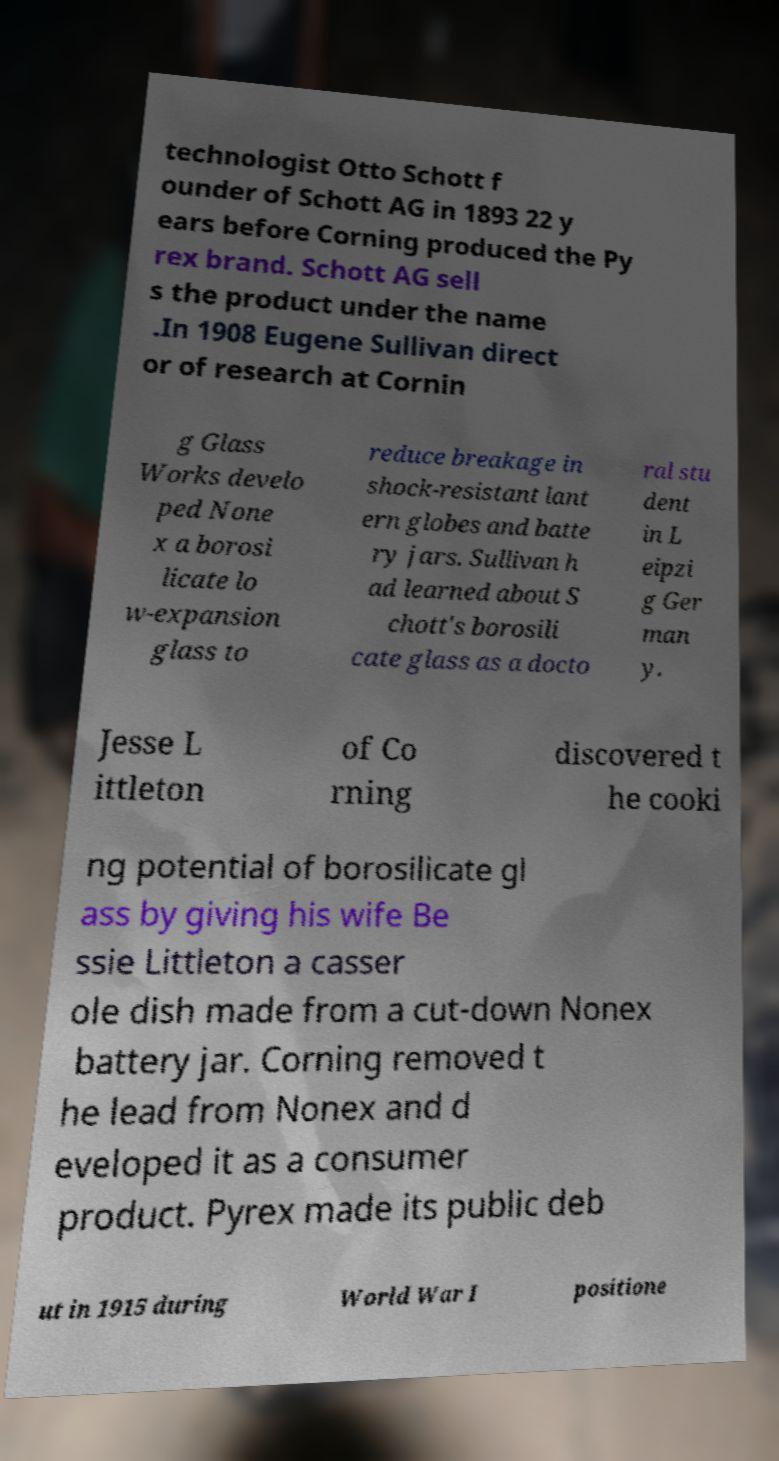There's text embedded in this image that I need extracted. Can you transcribe it verbatim? technologist Otto Schott f ounder of Schott AG in 1893 22 y ears before Corning produced the Py rex brand. Schott AG sell s the product under the name .In 1908 Eugene Sullivan direct or of research at Cornin g Glass Works develo ped None x a borosi licate lo w-expansion glass to reduce breakage in shock-resistant lant ern globes and batte ry jars. Sullivan h ad learned about S chott's borosili cate glass as a docto ral stu dent in L eipzi g Ger man y. Jesse L ittleton of Co rning discovered t he cooki ng potential of borosilicate gl ass by giving his wife Be ssie Littleton a casser ole dish made from a cut-down Nonex battery jar. Corning removed t he lead from Nonex and d eveloped it as a consumer product. Pyrex made its public deb ut in 1915 during World War I positione 